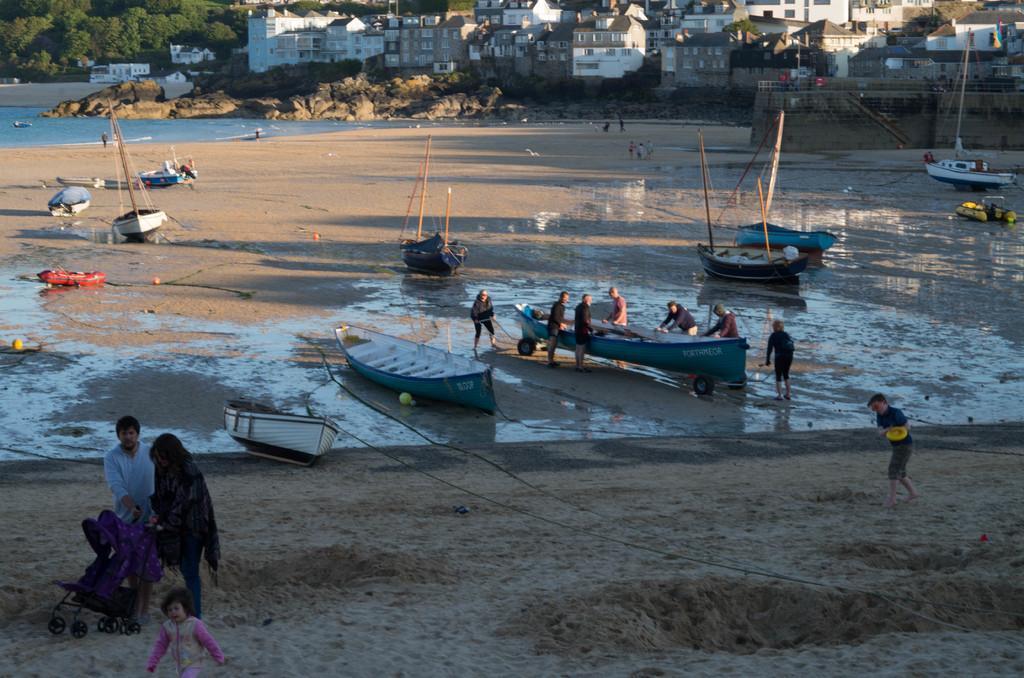Please provide a concise description of this image. In this image we can see many buildings. There is a beach in the image. There are many watercraft in the image. There are few people at the left side of the image. We can see few people standing near a watercraft. We can many trees at the top left corner of the image. There is some water in the image. 